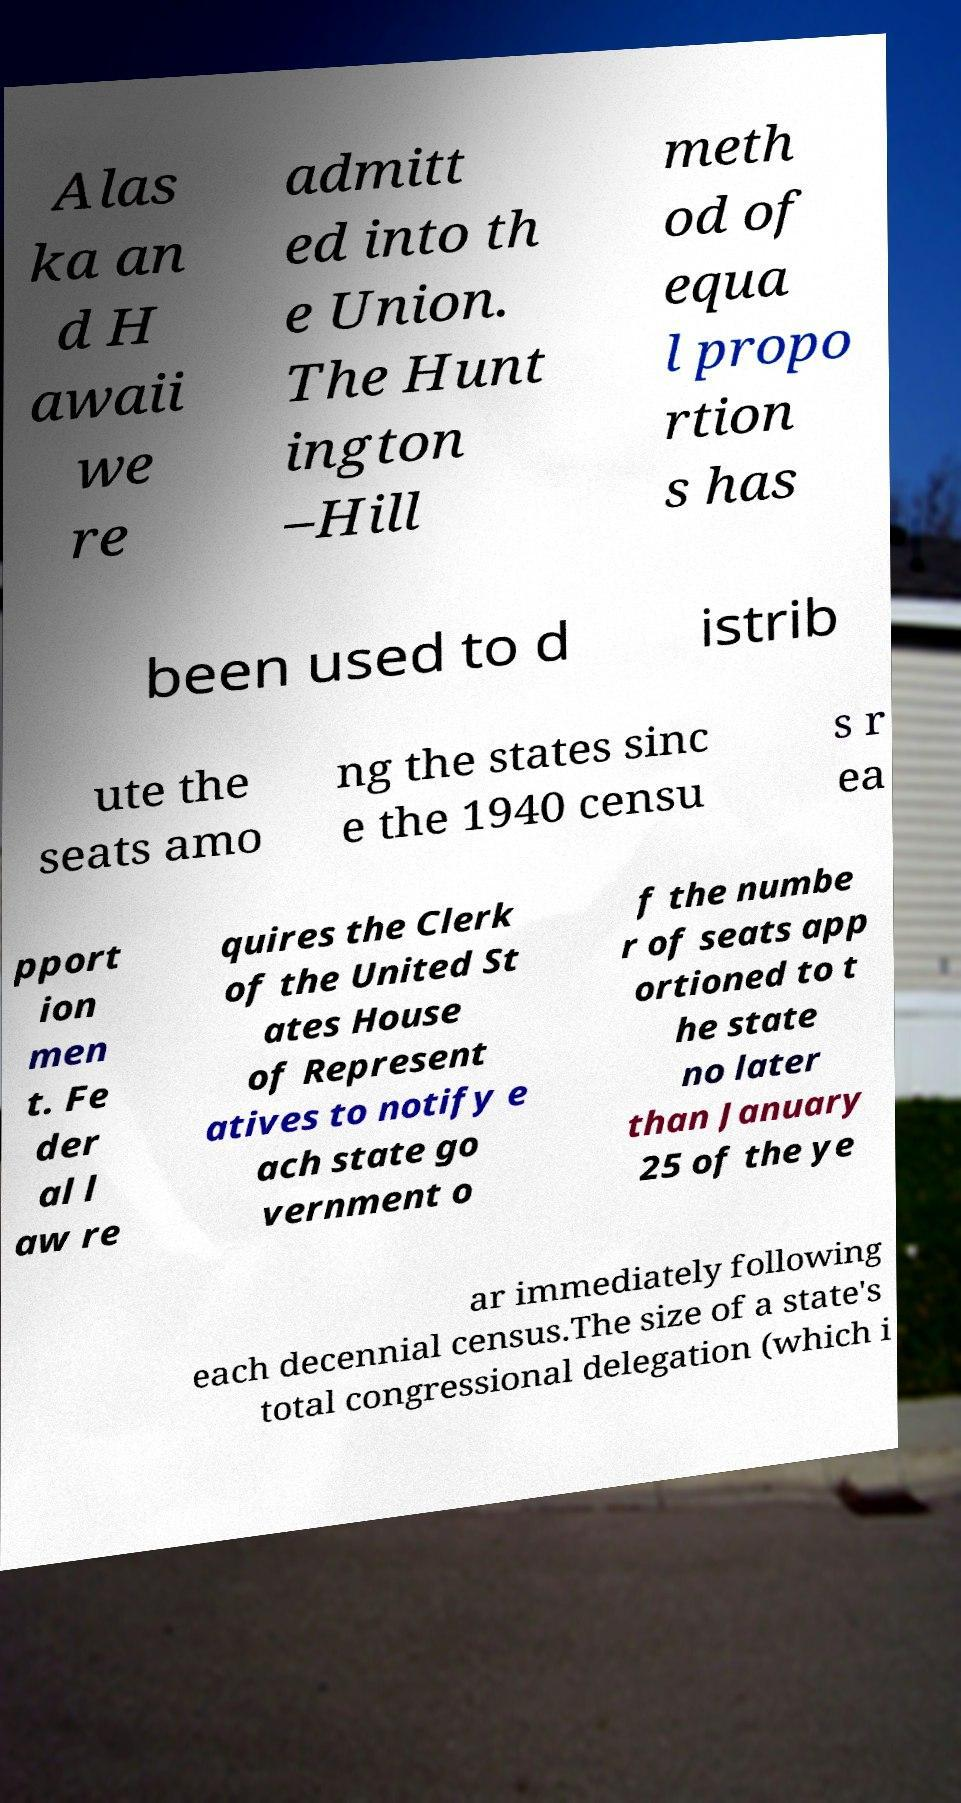Could you extract and type out the text from this image? Alas ka an d H awaii we re admitt ed into th e Union. The Hunt ington –Hill meth od of equa l propo rtion s has been used to d istrib ute the seats amo ng the states sinc e the 1940 censu s r ea pport ion men t. Fe der al l aw re quires the Clerk of the United St ates House of Represent atives to notify e ach state go vernment o f the numbe r of seats app ortioned to t he state no later than January 25 of the ye ar immediately following each decennial census.The size of a state's total congressional delegation (which i 